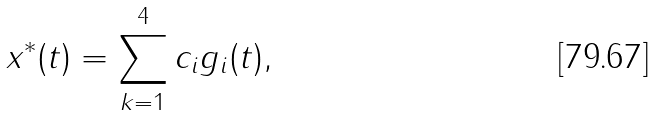<formula> <loc_0><loc_0><loc_500><loc_500>x ^ { * } ( t ) = \sum _ { k = 1 } ^ { 4 } c _ { i } g _ { i } ( t ) ,</formula> 